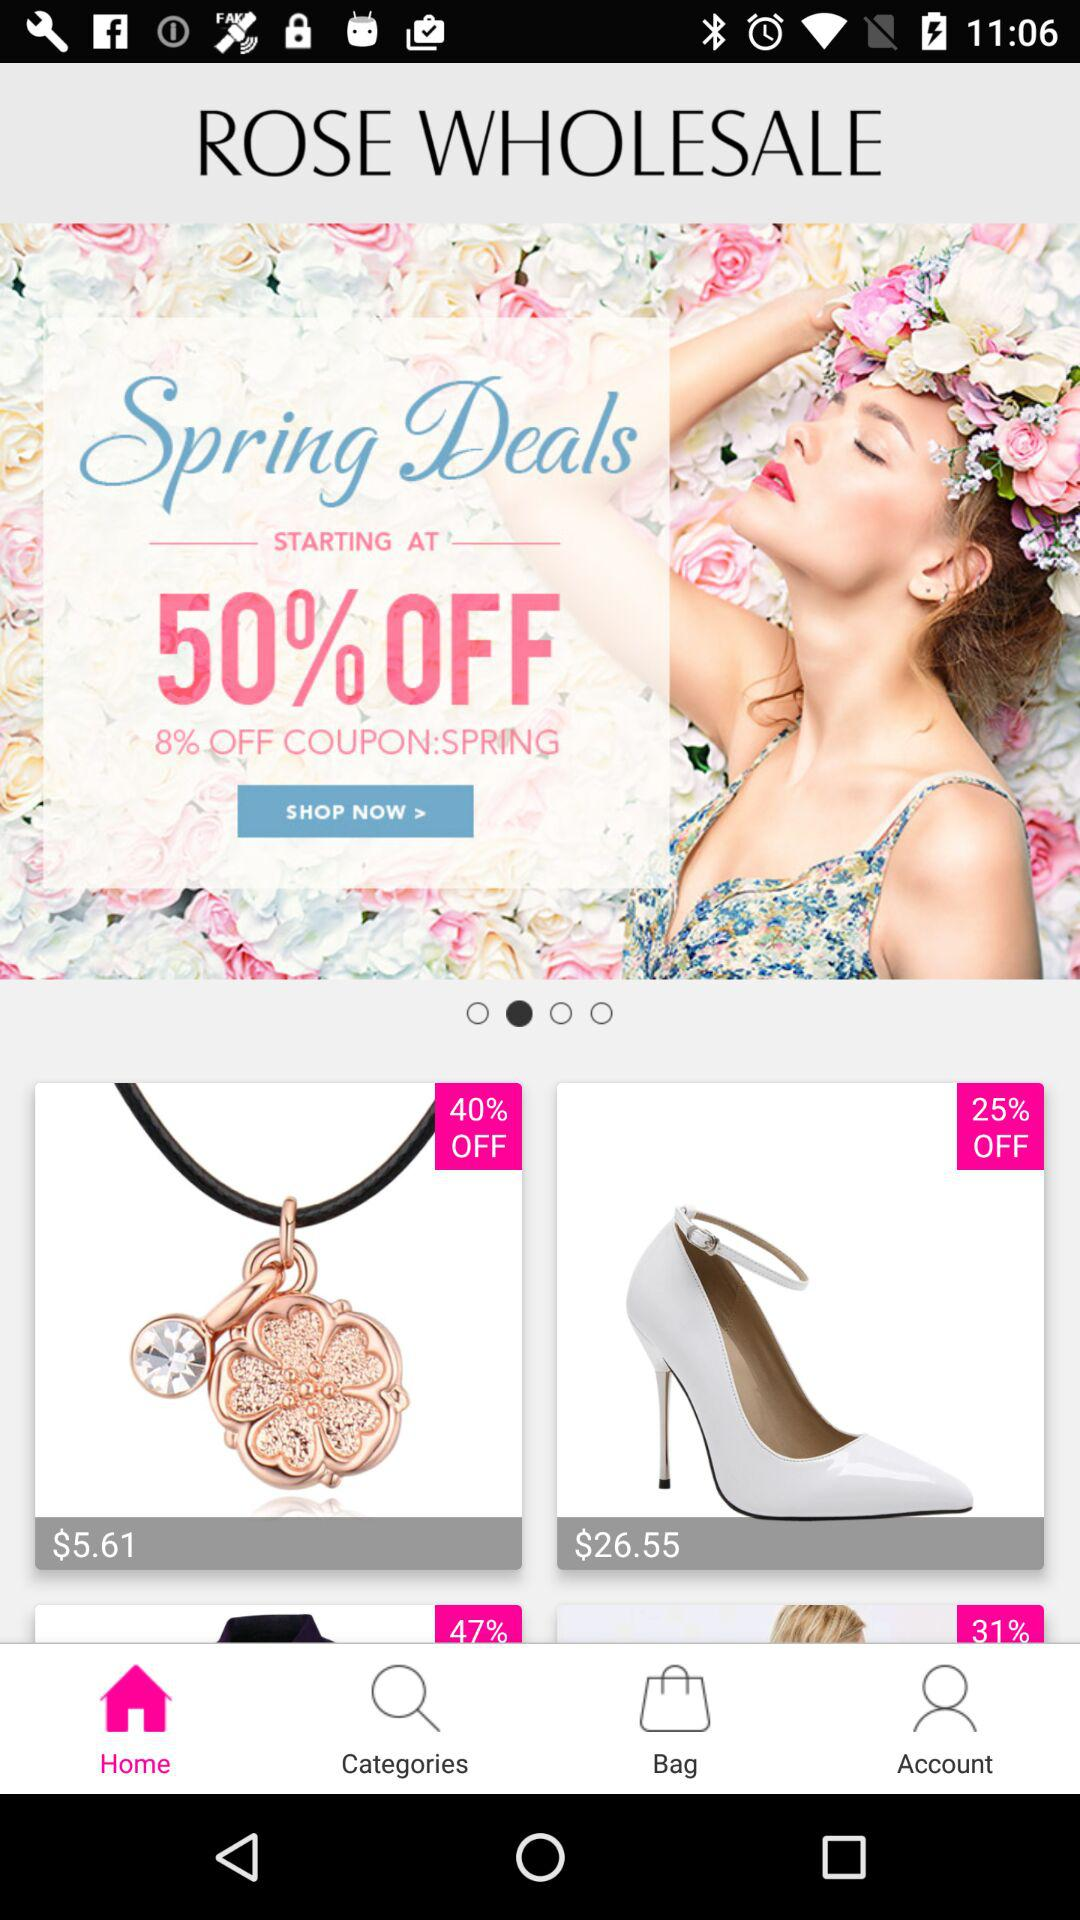What is the discount percentage on spring deals? The discount percentage on spring deals starts at 50% off. 